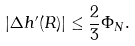Convert formula to latex. <formula><loc_0><loc_0><loc_500><loc_500>| \Delta h ^ { \prime } ( R ) | \leq \frac { 2 } { 3 } \Phi _ { N } .</formula> 